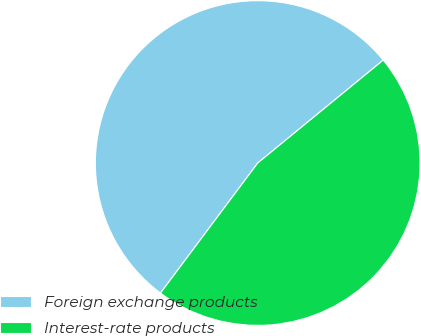Convert chart to OTSL. <chart><loc_0><loc_0><loc_500><loc_500><pie_chart><fcel>Foreign exchange products<fcel>Interest-rate products<nl><fcel>53.85%<fcel>46.15%<nl></chart> 